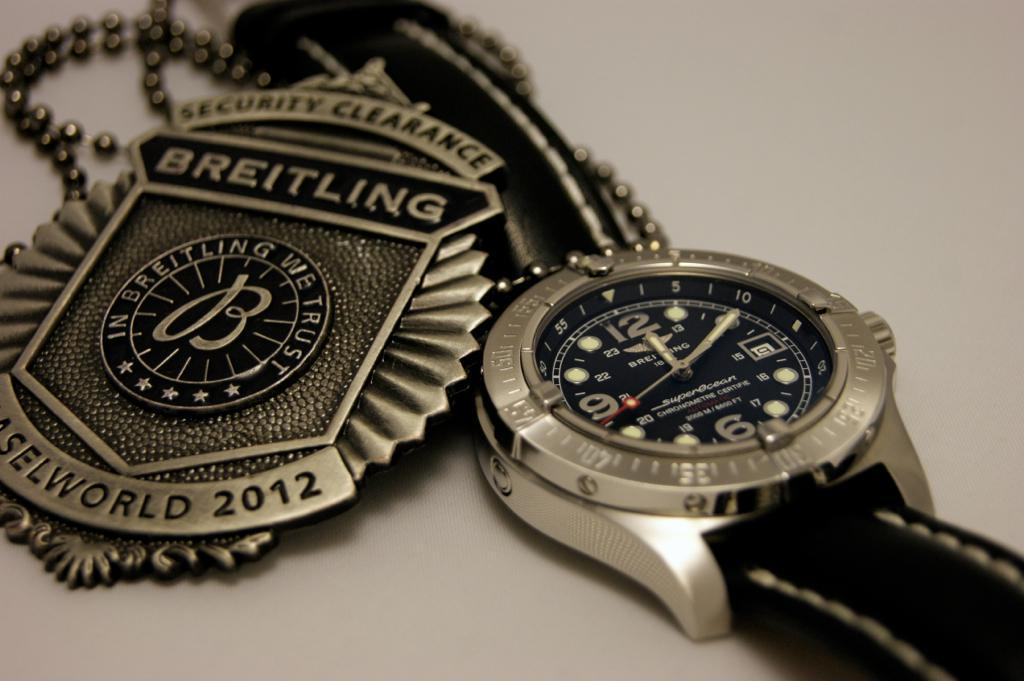Provide a one-sentence caption for the provided image. Wristwatch next to a logo which says Breitling on it. 